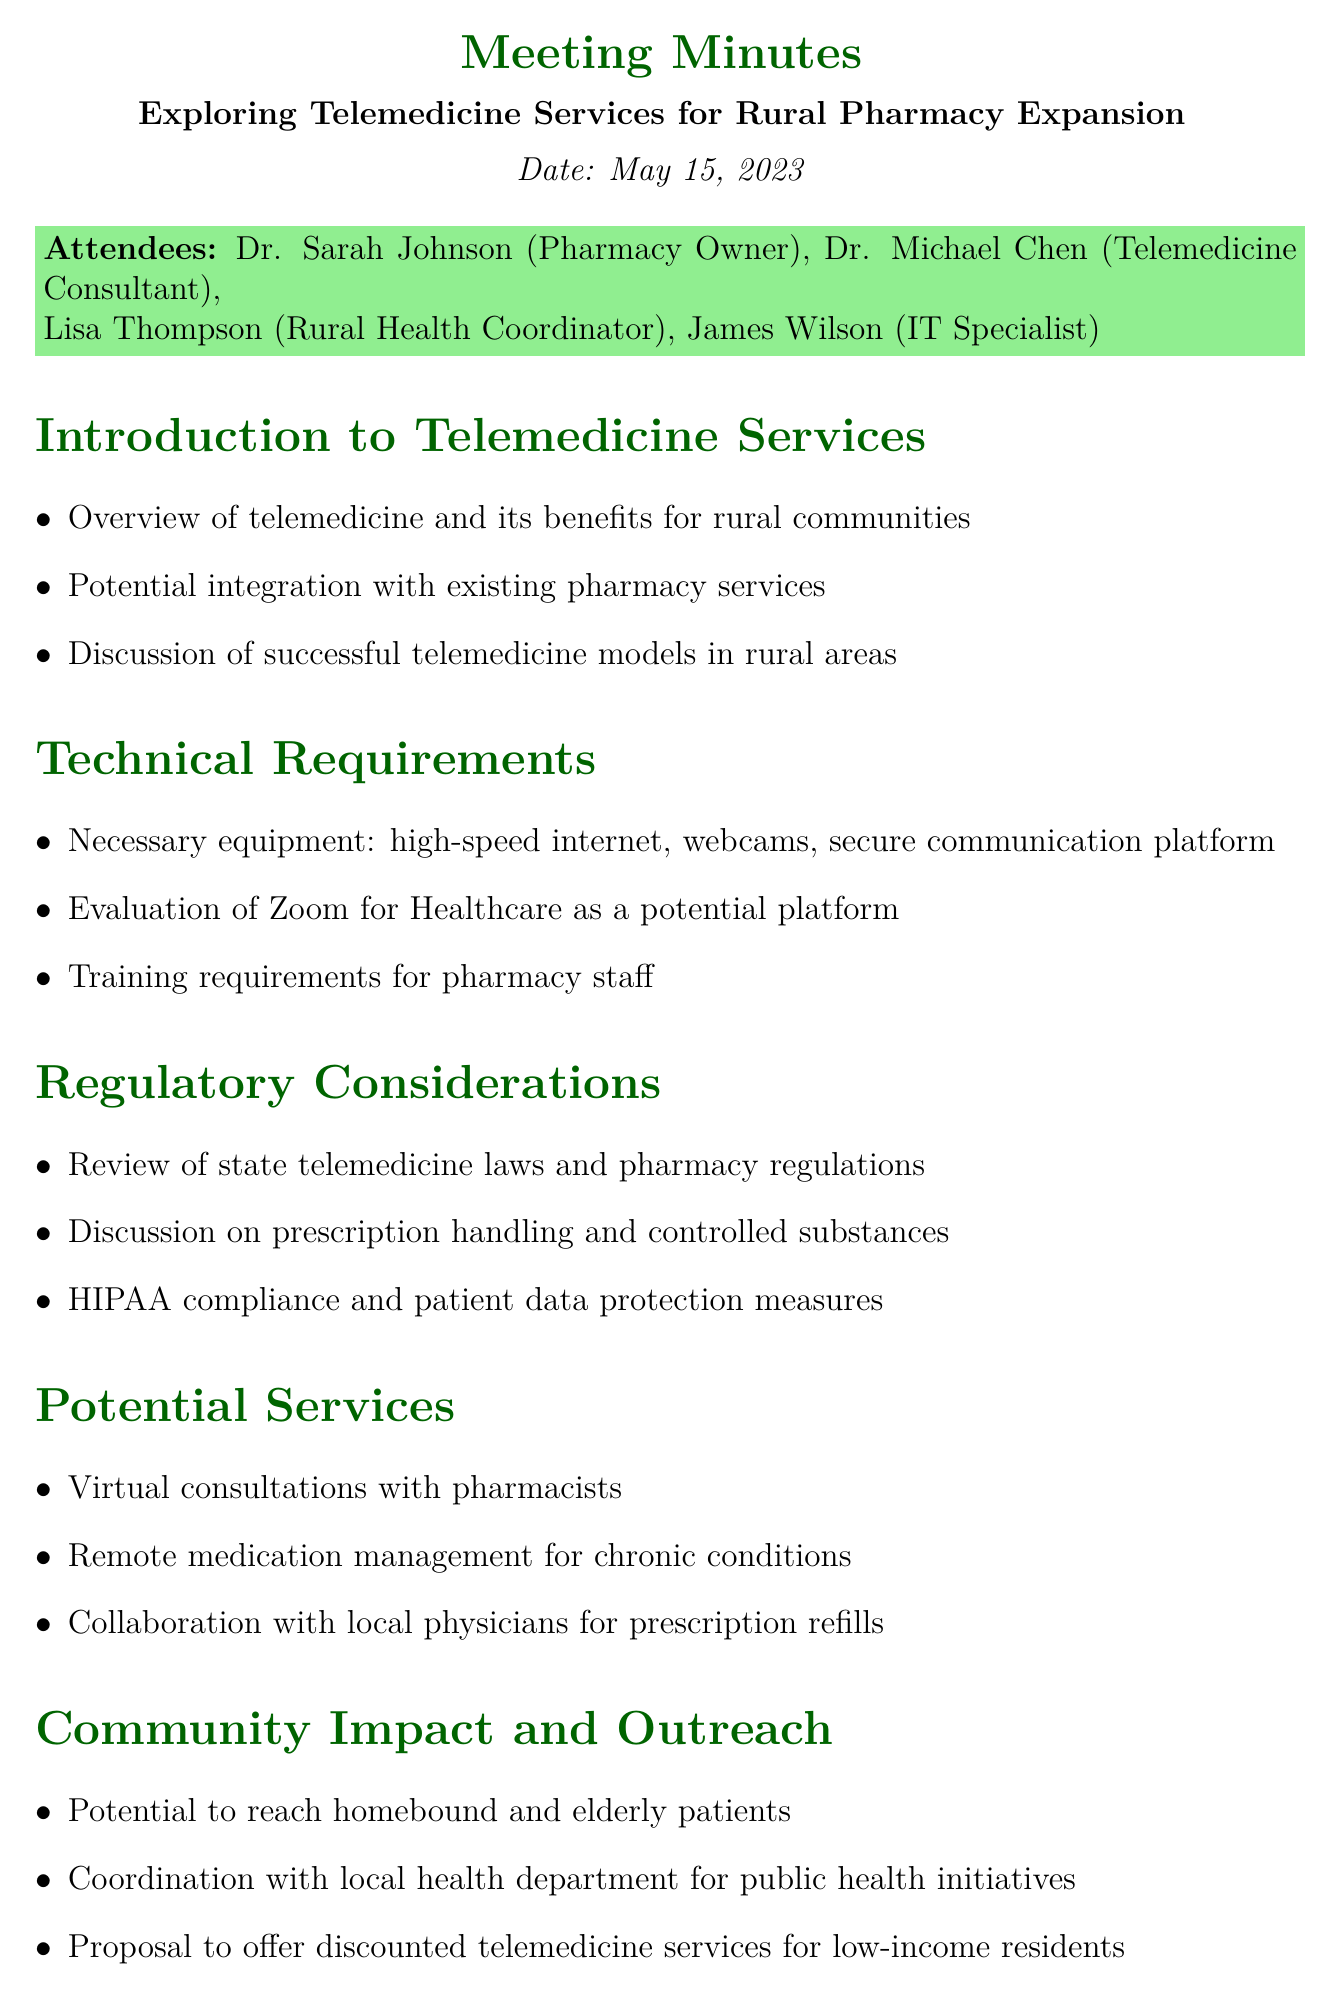What is the meeting date? The meeting date is explicitly stated in the document under the title.
Answer: May 15, 2023 Who is listed as the Telemedicine Consultant? The document specifies the attendees and their roles, including the Telemedicine Consultant.
Answer: Dr. Michael Chen What service was proposed for low-income residents? The agenda item discusses potential services, including discounted options for a specific group.
Answer: Discounted telemedicine services What platform is being evaluated for telemedicine? The document mentions a specific telecommunication platform that is being considered for pharmacy use.
Answer: Zoom for Healthcare What is one of the proposed services for pharmacists? The document lists specific services that could be offered, focusing on a role played by pharmacists.
Answer: Virtual consultations How many attendees were present in the meeting? The number of attendees can be counted from the attendees section of the document.
Answer: Four What is the next step regarding St. Mary's Rural Health Clinic? The document outlines future actions and mentions a specific partnership aimed at expanding services.
Answer: Develop partnership What is a requirement for pharmacy staff in relation to telemedicine? The technical requirements section includes training as a necessity for staff regarding new operations.
Answer: Training requirements 